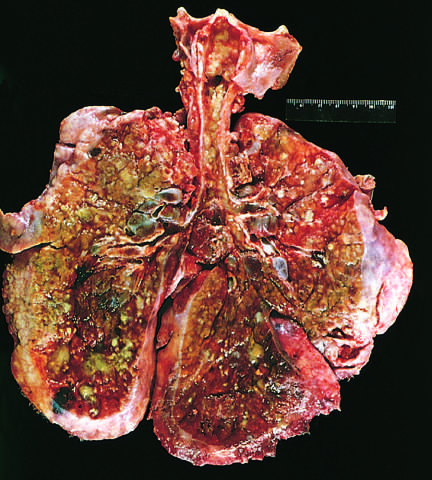what is the greenish discoloration?
Answer the question using a single word or phrase. The product of pseudomonas infections 